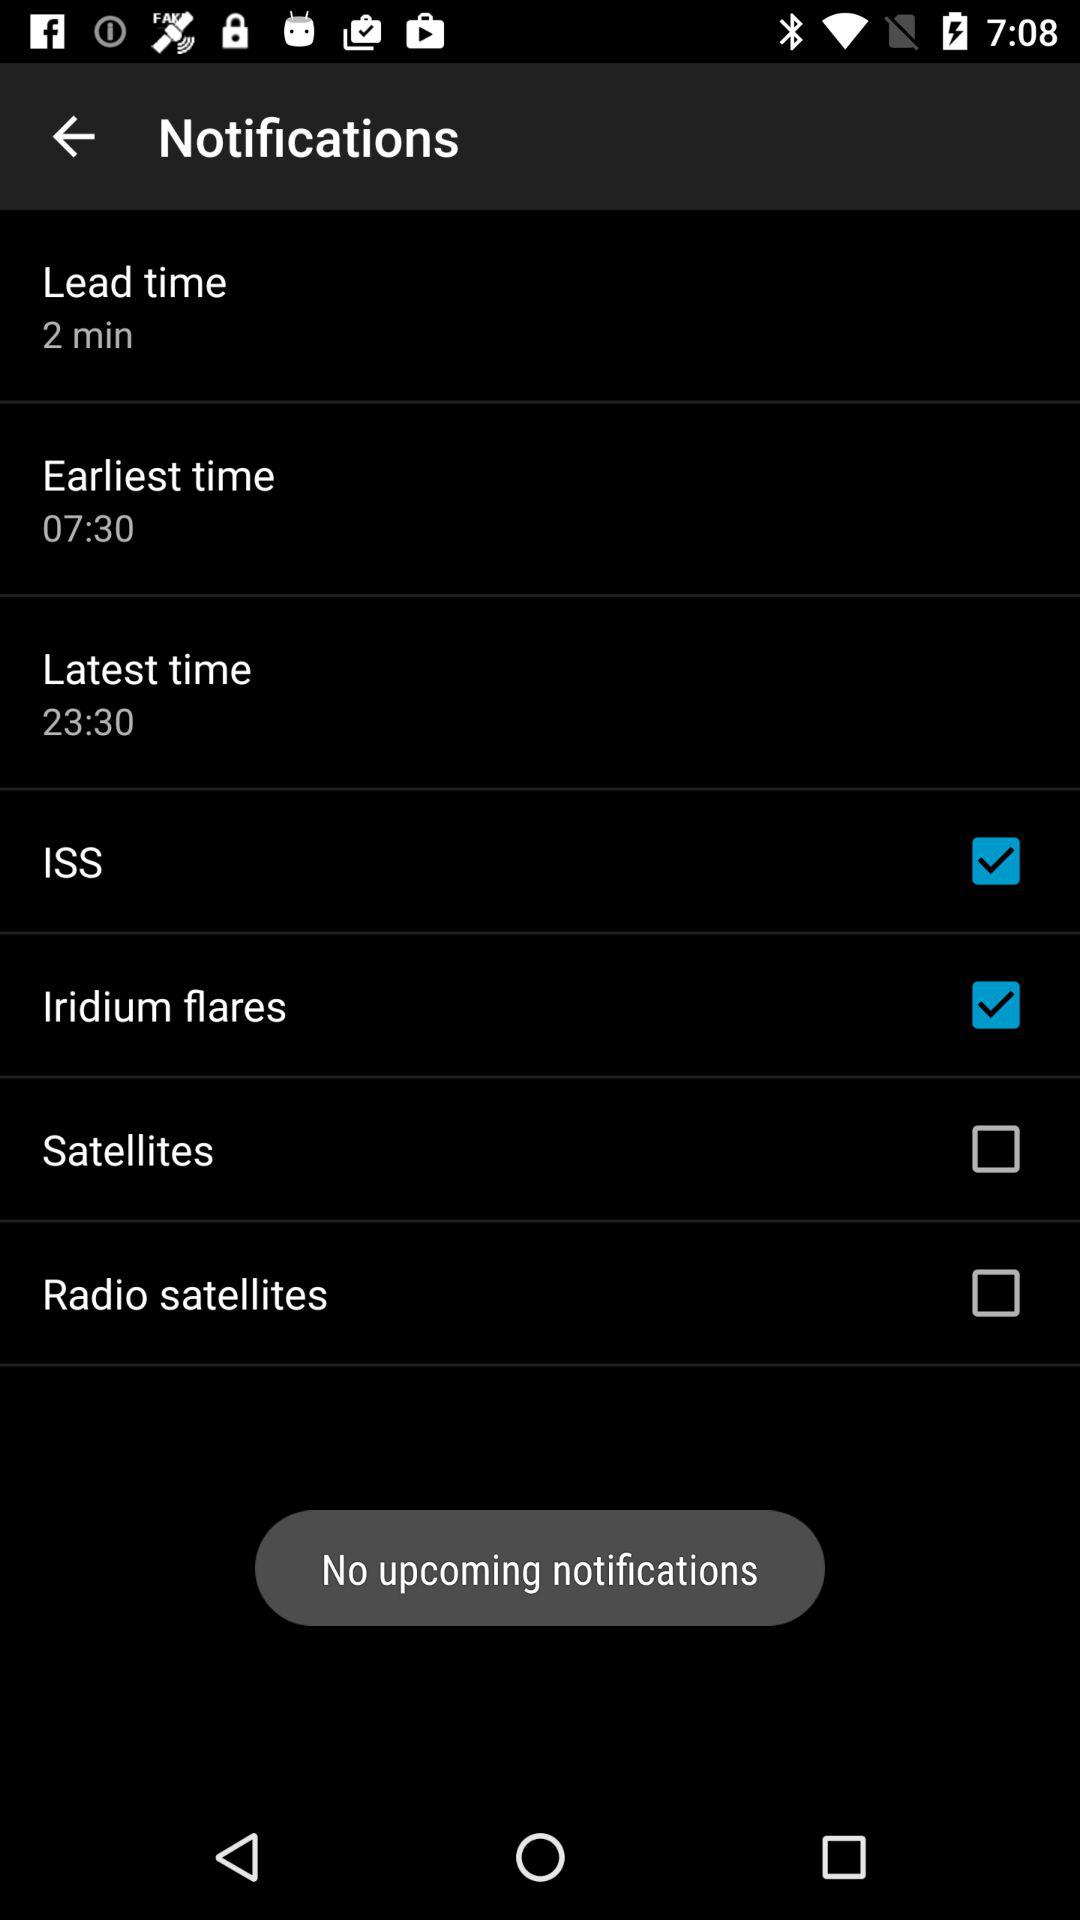What is the status of "Iridium flares"? The status is on. 